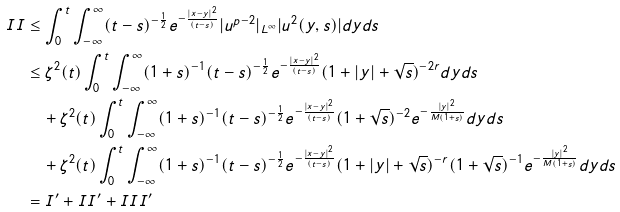<formula> <loc_0><loc_0><loc_500><loc_500>I I & \leq \int _ { 0 } ^ { t } \int _ { - \infty } ^ { \infty } ( t - s ) ^ { - \frac { 1 } { 2 } } e ^ { - \frac { | x - y | ^ { 2 } } { ( t - s ) } } | u ^ { p - 2 } | _ { L ^ { \infty } } | u ^ { 2 } ( y , s ) | d y d s \\ & \leq \zeta ^ { 2 } ( t ) \int _ { 0 } ^ { t } \int _ { - \infty } ^ { \infty } ( 1 + s ) ^ { - 1 } ( t - s ) ^ { - \frac { 1 } { 2 } } e ^ { - \frac { | x - y | ^ { 2 } } { ( t - s ) } } ( 1 + | y | + \sqrt { s } ) ^ { - 2 r } d y d s \\ & \quad + \zeta ^ { 2 } ( t ) \int _ { 0 } ^ { t } \int _ { - \infty } ^ { \infty } ( 1 + s ) ^ { - 1 } ( t - s ) ^ { - \frac { 1 } { 2 } } e ^ { - \frac { | x - y | ^ { 2 } } { ( t - s ) } } ( 1 + \sqrt { s } ) ^ { - 2 } e ^ { - \frac { | y | ^ { 2 } } { M ( 1 + s ) } } d y d s \\ & \quad + \zeta ^ { 2 } ( t ) \int _ { 0 } ^ { t } \int _ { - \infty } ^ { \infty } ( 1 + s ) ^ { - 1 } ( t - s ) ^ { - \frac { 1 } { 2 } } e ^ { - \frac { | x - y | ^ { 2 } } { ( t - s ) } } ( 1 + | y | + \sqrt { s } ) ^ { - r } ( 1 + \sqrt { s } ) ^ { - 1 } e ^ { - \frac { | y | ^ { 2 } } { M ( 1 + s ) } } d y d s \\ & = I ^ { \prime } + I I ^ { \prime } + I I I ^ { \prime }</formula> 